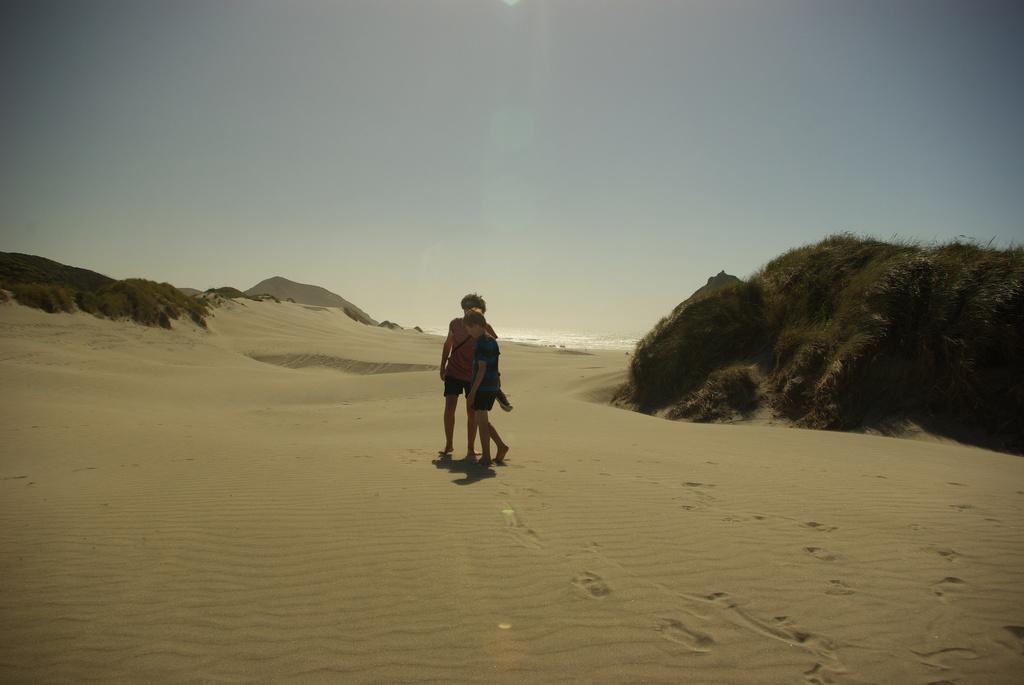Can you describe this image briefly? In this image there are two persons walking on the ground. There is sand on the ground. It seems to be a dessert. On the either sides of the image there are mountains. At the top there is the sky. 